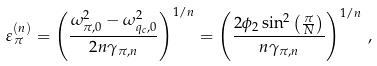Convert formula to latex. <formula><loc_0><loc_0><loc_500><loc_500>\varepsilon _ { \pi } ^ { ( n ) } = \left ( \frac { \omega ^ { 2 } _ { \pi , 0 } - \omega ^ { 2 } _ { q _ { c } , 0 } } { 2 n \gamma _ { \pi , n } } \right ) ^ { 1 / n } = \left ( \frac { 2 \phi _ { 2 } \sin ^ { 2 } \left ( \frac { \pi } { N } \right ) } { n \gamma _ { \pi , n } } \right ) ^ { 1 / n } \, ,</formula> 